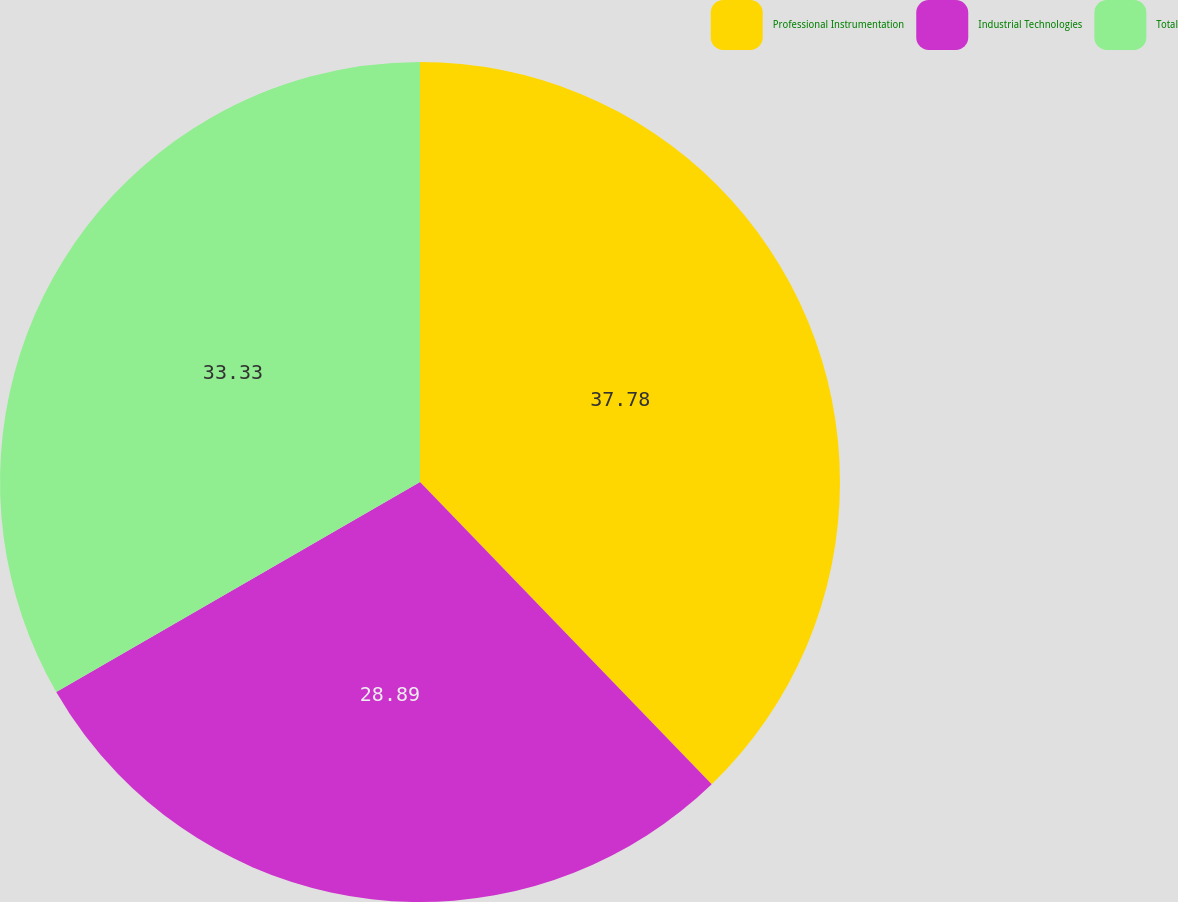<chart> <loc_0><loc_0><loc_500><loc_500><pie_chart><fcel>Professional Instrumentation<fcel>Industrial Technologies<fcel>Total<nl><fcel>37.78%<fcel>28.89%<fcel>33.33%<nl></chart> 